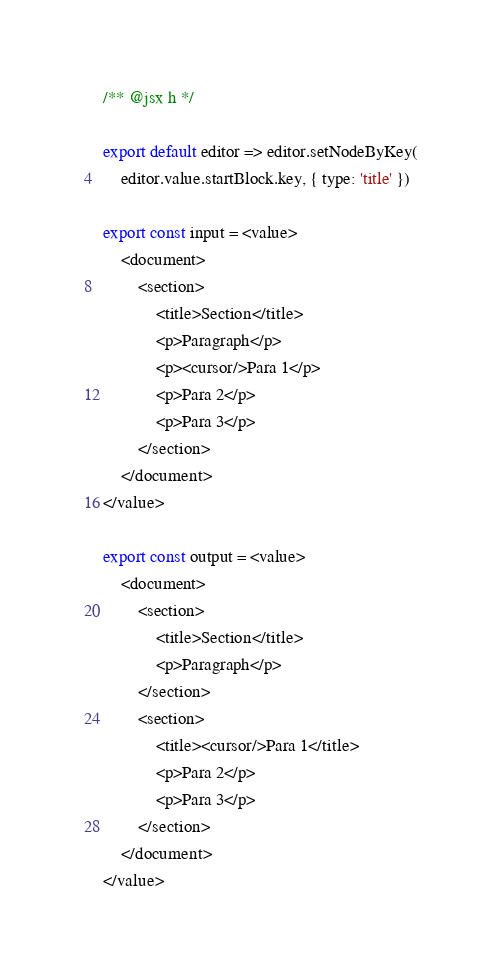Convert code to text. <code><loc_0><loc_0><loc_500><loc_500><_JavaScript_>/** @jsx h */

export default editor => editor.setNodeByKey(
    editor.value.startBlock.key, { type: 'title' })

export const input = <value>
    <document>
        <section>
            <title>Section</title>
            <p>Paragraph</p>
            <p><cursor/>Para 1</p>
            <p>Para 2</p>
            <p>Para 3</p>
        </section>
    </document>
</value>

export const output = <value>
    <document>
        <section>
            <title>Section</title>
            <p>Paragraph</p>
        </section>
        <section>
            <title><cursor/>Para 1</title>
            <p>Para 2</p>
            <p>Para 3</p>
        </section>
    </document>
</value>
</code> 